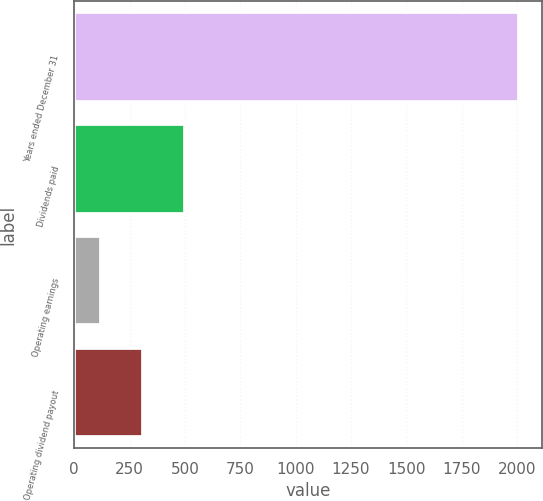Convert chart to OTSL. <chart><loc_0><loc_0><loc_500><loc_500><bar_chart><fcel>Years ended December 31<fcel>Dividends paid<fcel>Operating earnings<fcel>Operating dividend payout<nl><fcel>2010<fcel>499.76<fcel>122.2<fcel>310.98<nl></chart> 